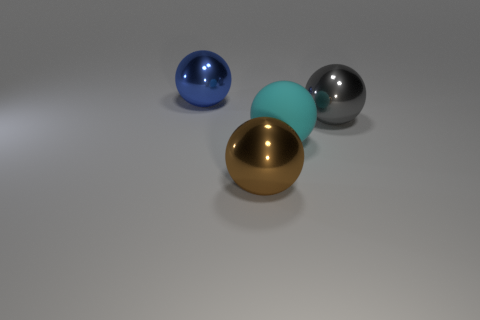Add 3 large yellow rubber balls. How many objects exist? 7 Add 2 brown balls. How many brown balls are left? 3 Add 1 large purple rubber cylinders. How many large purple rubber cylinders exist? 1 Subtract 0 brown cubes. How many objects are left? 4 Subtract all large cyan matte things. Subtract all big rubber balls. How many objects are left? 2 